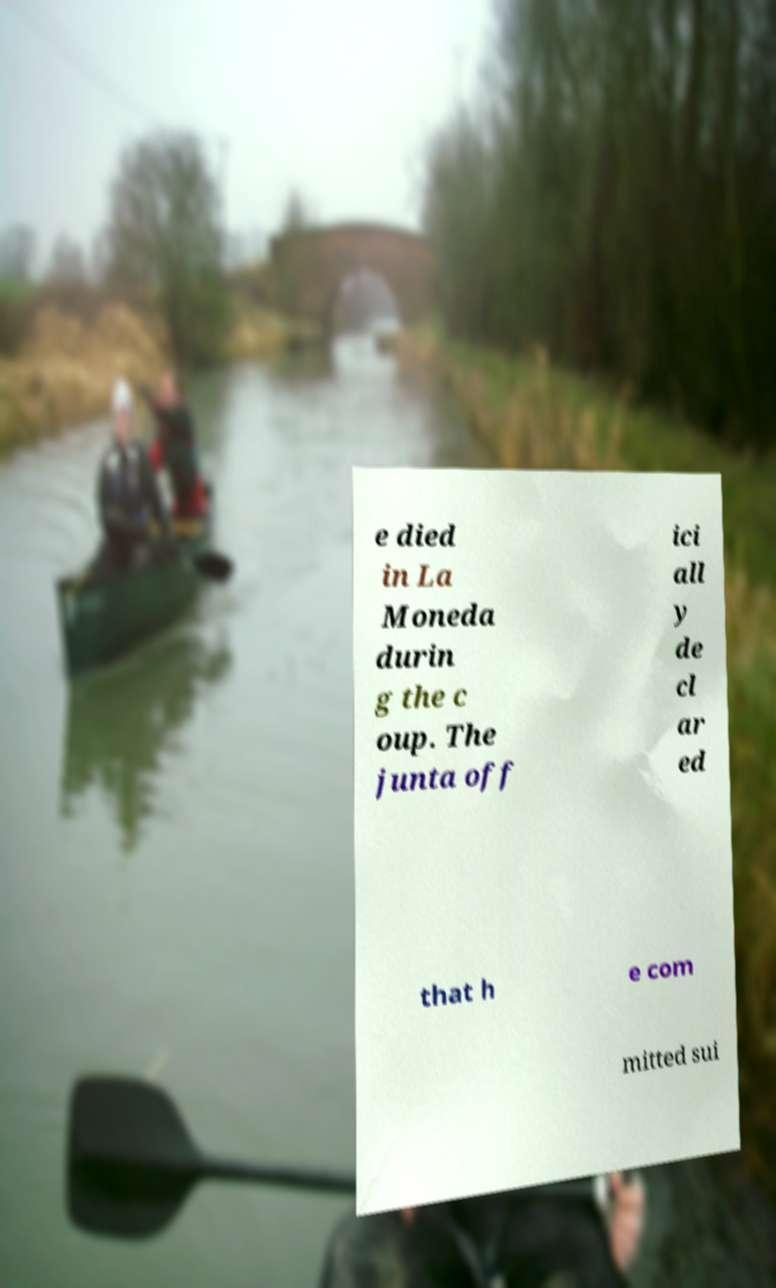Please read and relay the text visible in this image. What does it say? e died in La Moneda durin g the c oup. The junta off ici all y de cl ar ed that h e com mitted sui 